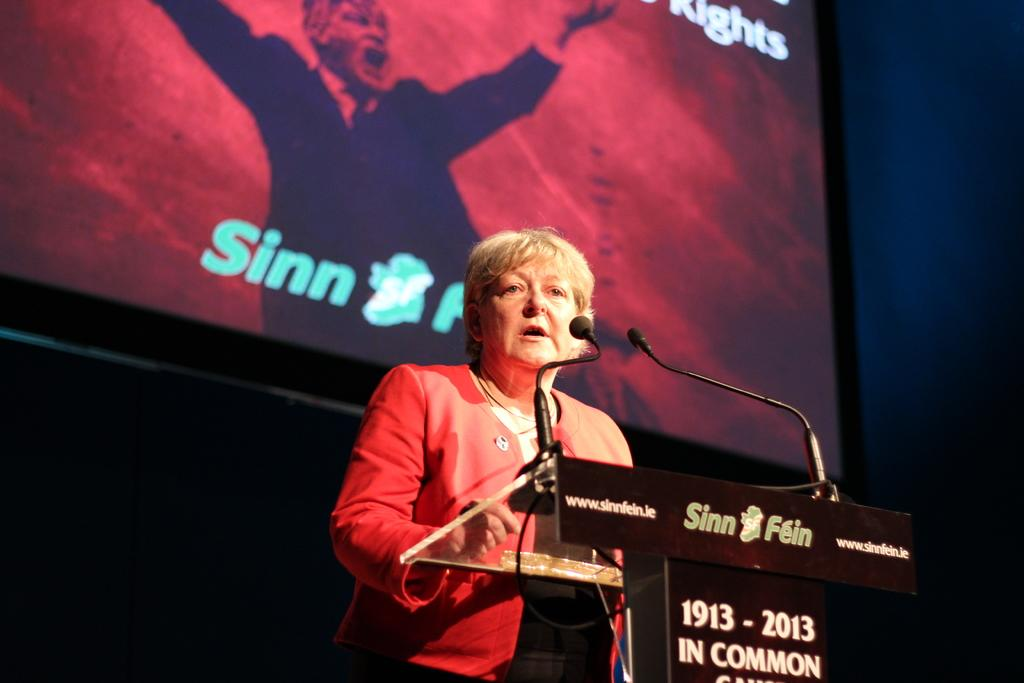<image>
Render a clear and concise summary of the photo. A woman giving a speech, with a podium in front of her that says Sinn Fein 